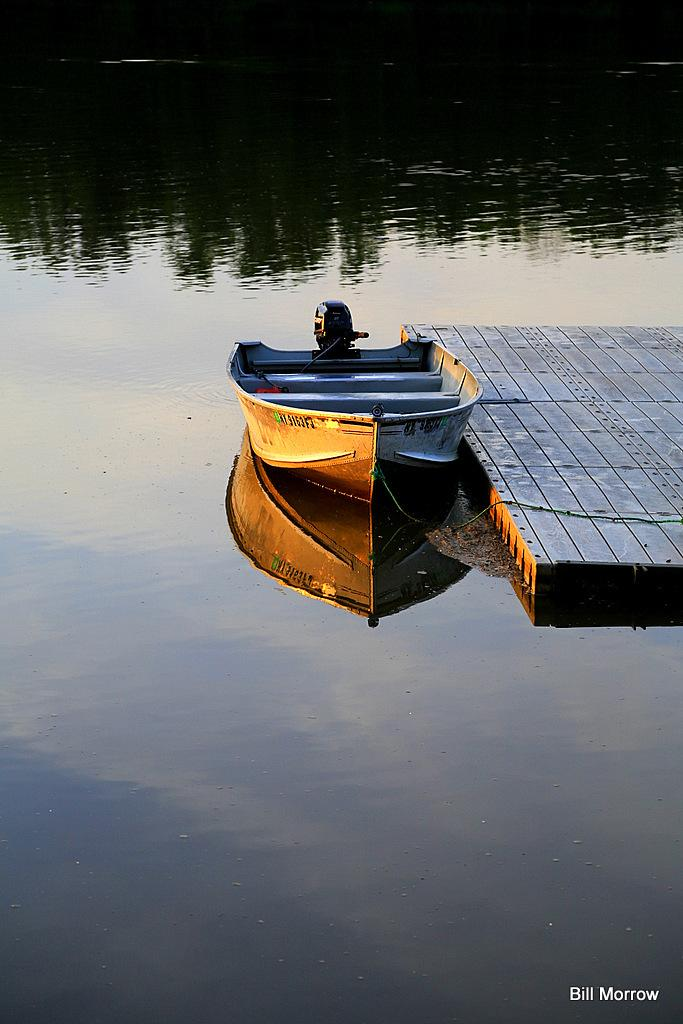What is the main subject of the image? The main subject of the image is a boat. Can you describe anything else related to the boat? There is a raft behind the boat. What type of environment is depicted in the image? There is water visible in the image. Is there any text present in the image? Yes, there is some text present in the image. What type of bean is growing in the field in the image? There is no field or bean present in the image; it features a boat and a raft in the water. 